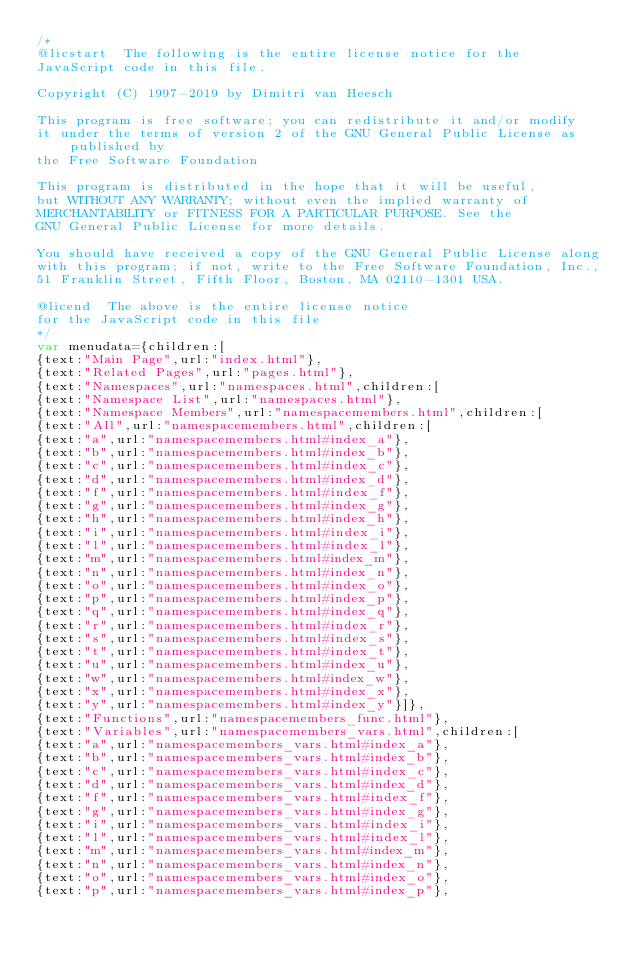Convert code to text. <code><loc_0><loc_0><loc_500><loc_500><_JavaScript_>/*
@licstart  The following is the entire license notice for the
JavaScript code in this file.

Copyright (C) 1997-2019 by Dimitri van Heesch

This program is free software; you can redistribute it and/or modify
it under the terms of version 2 of the GNU General Public License as published by
the Free Software Foundation

This program is distributed in the hope that it will be useful,
but WITHOUT ANY WARRANTY; without even the implied warranty of
MERCHANTABILITY or FITNESS FOR A PARTICULAR PURPOSE. See the
GNU General Public License for more details.

You should have received a copy of the GNU General Public License along
with this program; if not, write to the Free Software Foundation, Inc.,
51 Franklin Street, Fifth Floor, Boston, MA 02110-1301 USA.

@licend  The above is the entire license notice
for the JavaScript code in this file
*/
var menudata={children:[
{text:"Main Page",url:"index.html"},
{text:"Related Pages",url:"pages.html"},
{text:"Namespaces",url:"namespaces.html",children:[
{text:"Namespace List",url:"namespaces.html"},
{text:"Namespace Members",url:"namespacemembers.html",children:[
{text:"All",url:"namespacemembers.html",children:[
{text:"a",url:"namespacemembers.html#index_a"},
{text:"b",url:"namespacemembers.html#index_b"},
{text:"c",url:"namespacemembers.html#index_c"},
{text:"d",url:"namespacemembers.html#index_d"},
{text:"f",url:"namespacemembers.html#index_f"},
{text:"g",url:"namespacemembers.html#index_g"},
{text:"h",url:"namespacemembers.html#index_h"},
{text:"i",url:"namespacemembers.html#index_i"},
{text:"l",url:"namespacemembers.html#index_l"},
{text:"m",url:"namespacemembers.html#index_m"},
{text:"n",url:"namespacemembers.html#index_n"},
{text:"o",url:"namespacemembers.html#index_o"},
{text:"p",url:"namespacemembers.html#index_p"},
{text:"q",url:"namespacemembers.html#index_q"},
{text:"r",url:"namespacemembers.html#index_r"},
{text:"s",url:"namespacemembers.html#index_s"},
{text:"t",url:"namespacemembers.html#index_t"},
{text:"u",url:"namespacemembers.html#index_u"},
{text:"w",url:"namespacemembers.html#index_w"},
{text:"x",url:"namespacemembers.html#index_x"},
{text:"y",url:"namespacemembers.html#index_y"}]},
{text:"Functions",url:"namespacemembers_func.html"},
{text:"Variables",url:"namespacemembers_vars.html",children:[
{text:"a",url:"namespacemembers_vars.html#index_a"},
{text:"b",url:"namespacemembers_vars.html#index_b"},
{text:"c",url:"namespacemembers_vars.html#index_c"},
{text:"d",url:"namespacemembers_vars.html#index_d"},
{text:"f",url:"namespacemembers_vars.html#index_f"},
{text:"g",url:"namespacemembers_vars.html#index_g"},
{text:"i",url:"namespacemembers_vars.html#index_i"},
{text:"l",url:"namespacemembers_vars.html#index_l"},
{text:"m",url:"namespacemembers_vars.html#index_m"},
{text:"n",url:"namespacemembers_vars.html#index_n"},
{text:"o",url:"namespacemembers_vars.html#index_o"},
{text:"p",url:"namespacemembers_vars.html#index_p"},</code> 